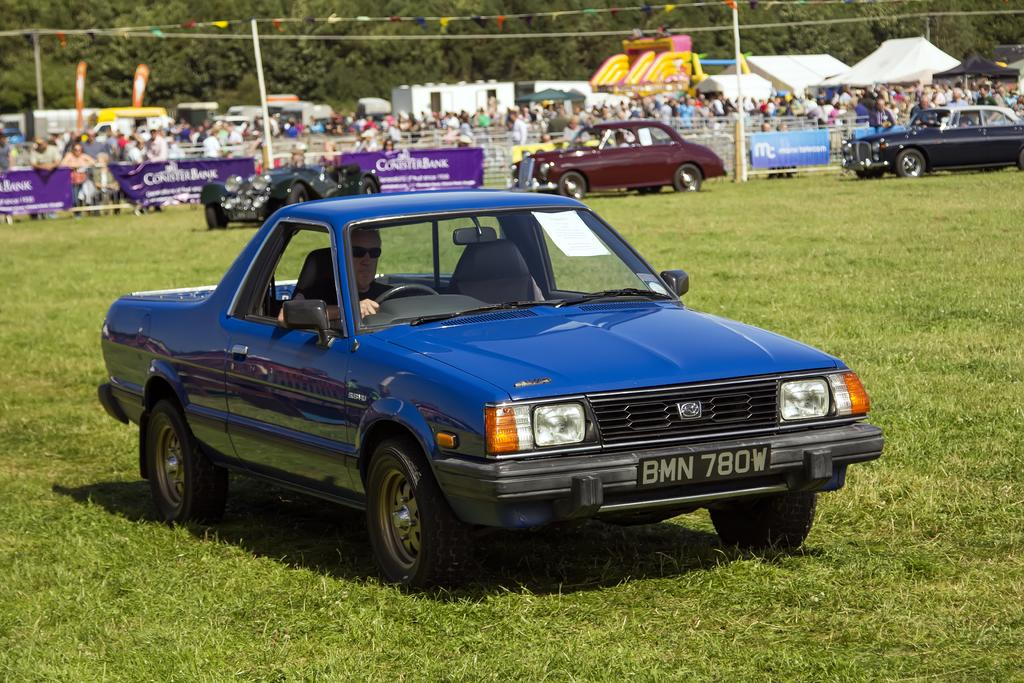How many cars are on the ground in the image? There are four cars on the ground in the image. What type of vegetation can be seen in the image? There is grass visible in the image. What decorative elements are present in the image? There are banners in the image. What can be seen in the background of the image? In the background, there are persons, a fence, poles, flags, tents, and trees. What type of cup is being used to hold the parcel in the image? There is no cup or parcel present in the image. Are any persons wearing masks in the image? There is no mention of masks in the image, so it cannot be determined if any persons are wearing them. 